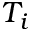<formula> <loc_0><loc_0><loc_500><loc_500>T _ { i }</formula> 